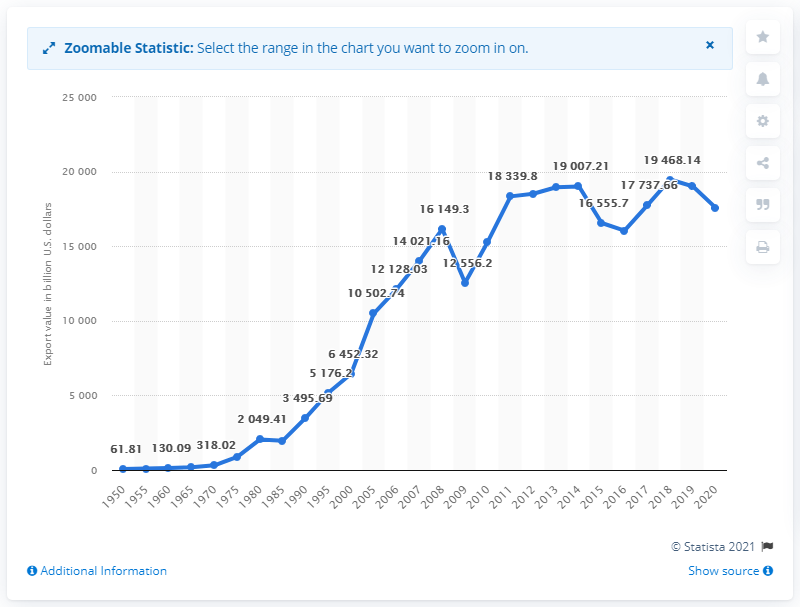Highlight a few significant elements in this photo. In the year 2000, the value of goods exported globally was approximately 64,523.2 million US dollars. In 2019, the global trade value of goods exported throughout the world amounted to approximately 190,14.76 billion U.S. dollars. 